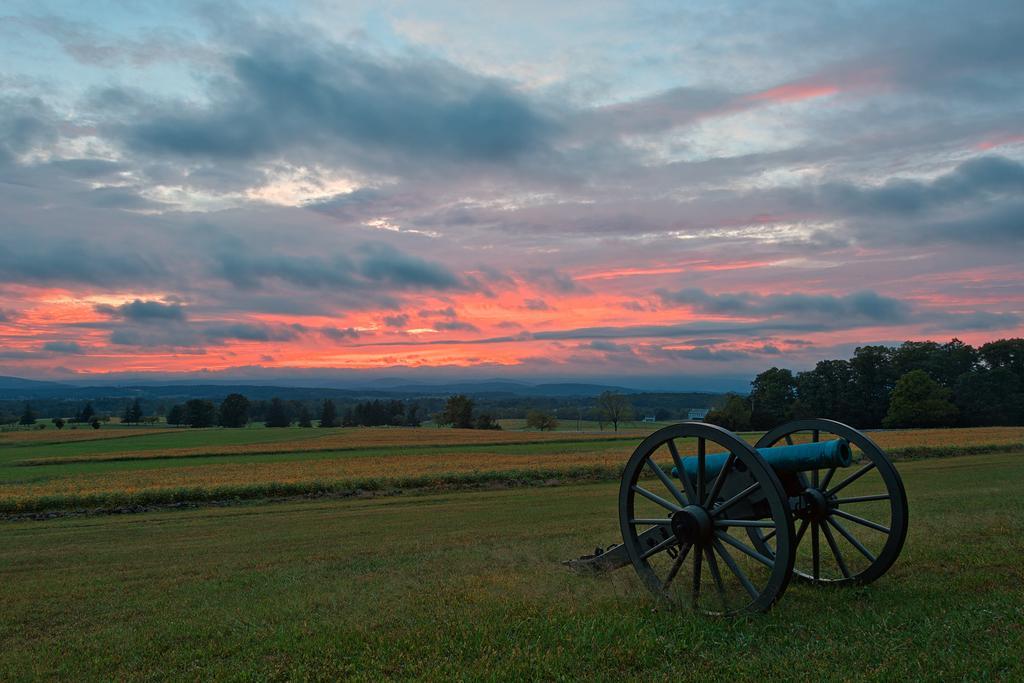Can you describe this image briefly? On the right side of the image we can see a canal. At the bottom there is grass. In the background there are trees, hills and sky. 